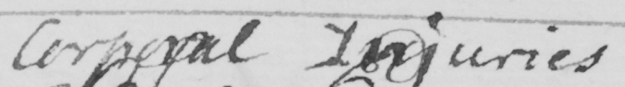Transcribe the text shown in this historical manuscript line. Corporal Injuries 